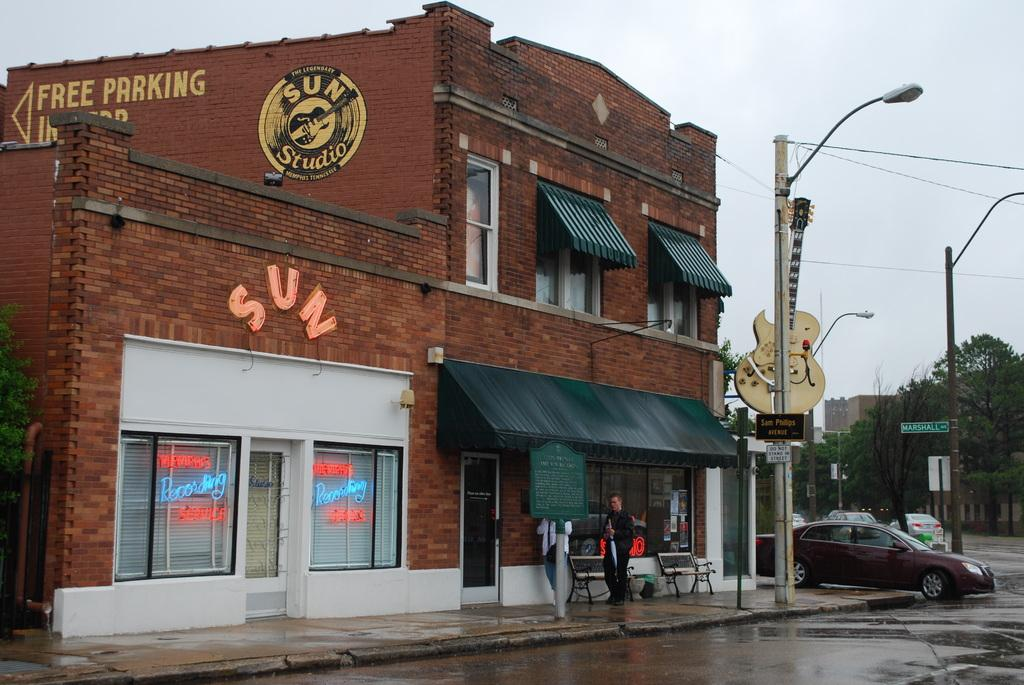Provide a one-sentence caption for the provided image. Sun Studio's building with Free Parking behind it. 